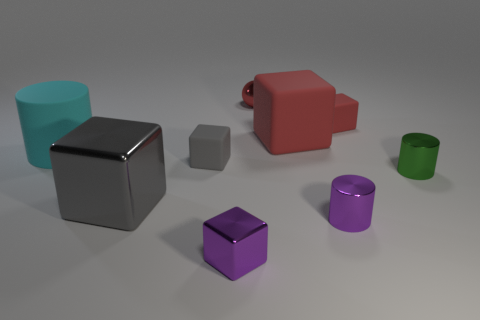There is a purple thing in front of the purple thing behind the purple thing that is left of the ball; what is its material?
Your answer should be very brief. Metal. There is a cylinder left of the purple cube; what material is it?
Offer a terse response. Rubber. Is there a gray matte cube of the same size as the cyan cylinder?
Give a very brief answer. No. There is a tiny cylinder left of the green thing; does it have the same color as the tiny metal block?
Make the answer very short. Yes. What number of green objects are either large matte cubes or tiny metallic balls?
Your response must be concise. 0. What number of metallic cylinders are the same color as the shiny ball?
Your response must be concise. 0. Does the green object have the same material as the sphere?
Offer a terse response. Yes. There is a red matte block that is on the left side of the tiny red rubber object; what number of red matte cubes are on the left side of it?
Your response must be concise. 0. Is the cyan matte cylinder the same size as the red ball?
Keep it short and to the point. No. How many small purple cylinders are the same material as the big gray thing?
Make the answer very short. 1. 